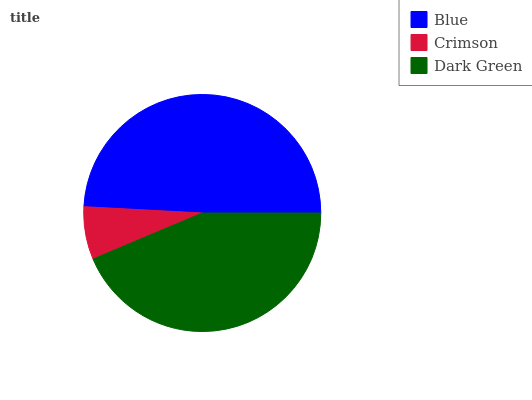Is Crimson the minimum?
Answer yes or no. Yes. Is Blue the maximum?
Answer yes or no. Yes. Is Dark Green the minimum?
Answer yes or no. No. Is Dark Green the maximum?
Answer yes or no. No. Is Dark Green greater than Crimson?
Answer yes or no. Yes. Is Crimson less than Dark Green?
Answer yes or no. Yes. Is Crimson greater than Dark Green?
Answer yes or no. No. Is Dark Green less than Crimson?
Answer yes or no. No. Is Dark Green the high median?
Answer yes or no. Yes. Is Dark Green the low median?
Answer yes or no. Yes. Is Crimson the high median?
Answer yes or no. No. Is Crimson the low median?
Answer yes or no. No. 